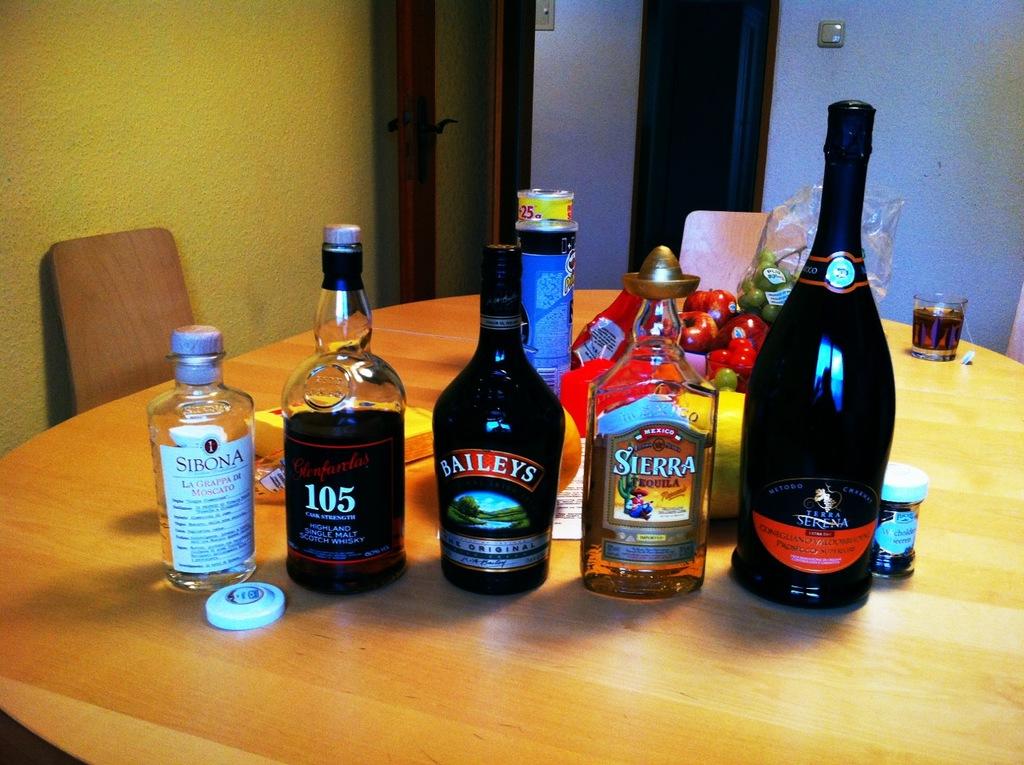What is the brand of alcohol on the far left?
Your response must be concise. Sibona. What number is on the bottle between the baileys and sibona bottles?
Keep it short and to the point. 105. 